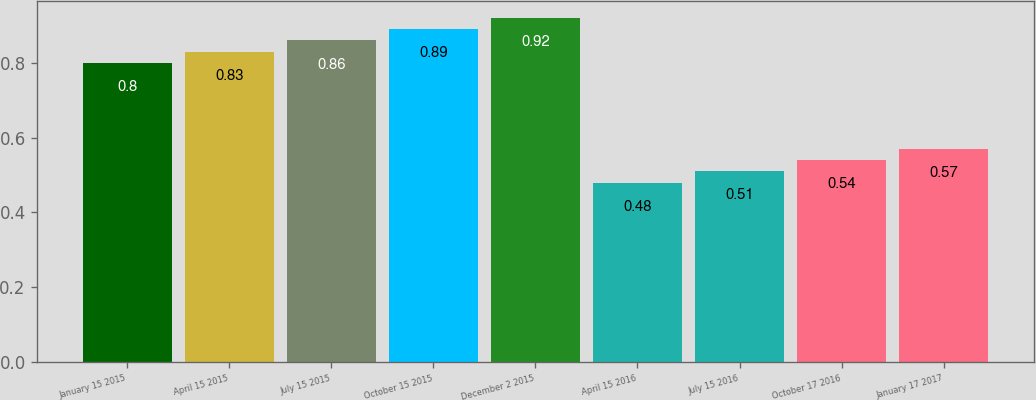Convert chart to OTSL. <chart><loc_0><loc_0><loc_500><loc_500><bar_chart><fcel>January 15 2015<fcel>April 15 2015<fcel>July 15 2015<fcel>October 15 2015<fcel>December 2 2015<fcel>April 15 2016<fcel>July 15 2016<fcel>October 17 2016<fcel>January 17 2017<nl><fcel>0.8<fcel>0.83<fcel>0.86<fcel>0.89<fcel>0.92<fcel>0.48<fcel>0.51<fcel>0.54<fcel>0.57<nl></chart> 